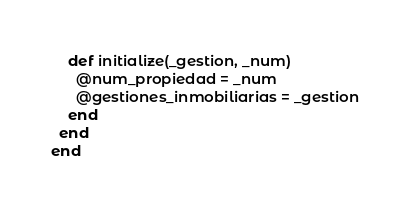Convert code to text. <code><loc_0><loc_0><loc_500><loc_500><_Ruby_>    def initialize(_gestion, _num)
      @num_propiedad = _num
      @gestiones_inmobiliarias = _gestion
    end
  end
end</code> 